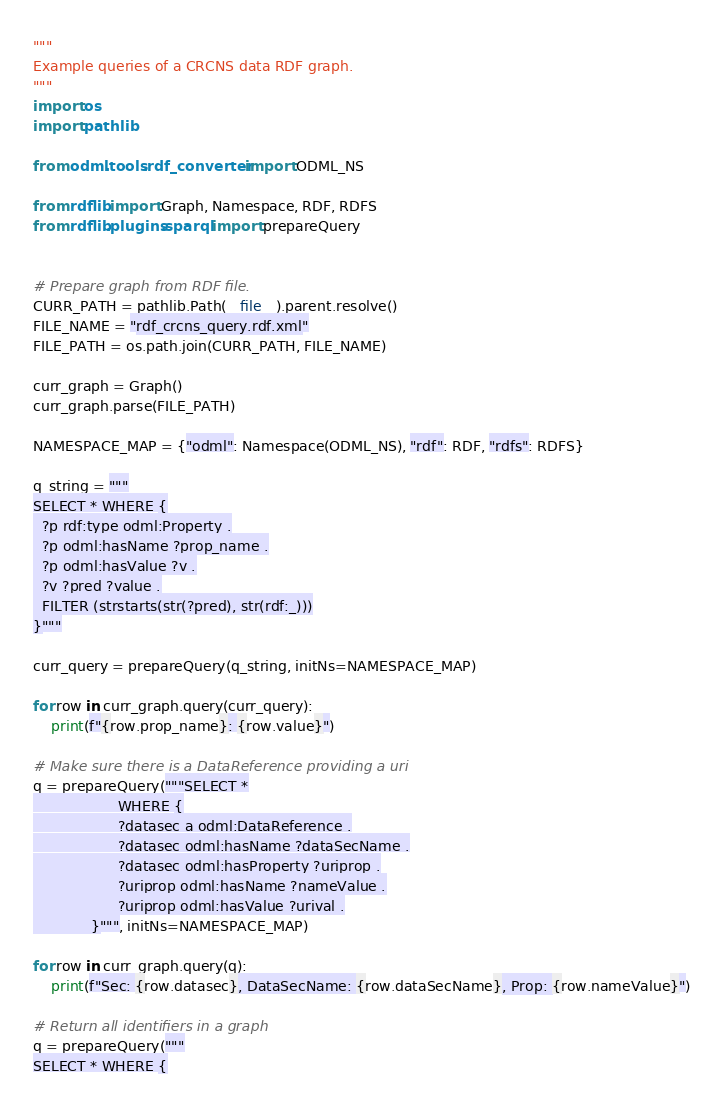Convert code to text. <code><loc_0><loc_0><loc_500><loc_500><_Python_>"""
Example queries of a CRCNS data RDF graph.
"""
import os
import pathlib

from odml.tools.rdf_converter import ODML_NS

from rdflib import Graph, Namespace, RDF, RDFS
from rdflib.plugins.sparql import prepareQuery


# Prepare graph from RDF file.
CURR_PATH = pathlib.Path(__file__).parent.resolve()
FILE_NAME = "rdf_crcns_query.rdf.xml"
FILE_PATH = os.path.join(CURR_PATH, FILE_NAME)

curr_graph = Graph()
curr_graph.parse(FILE_PATH)

NAMESPACE_MAP = {"odml": Namespace(ODML_NS), "rdf": RDF, "rdfs": RDFS}

q_string = """
SELECT * WHERE {
  ?p rdf:type odml:Property .
  ?p odml:hasName ?prop_name .
  ?p odml:hasValue ?v .
  ?v ?pred ?value .
  FILTER (strstarts(str(?pred), str(rdf:_)))
}"""

curr_query = prepareQuery(q_string, initNs=NAMESPACE_MAP)

for row in curr_graph.query(curr_query):
    print(f"{row.prop_name}: {row.value}")

# Make sure there is a DataReference providing a uri
q = prepareQuery("""SELECT *
                   WHERE {
                   ?datasec a odml:DataReference .
                   ?datasec odml:hasName ?dataSecName .
                   ?datasec odml:hasProperty ?uriprop .
                   ?uriprop odml:hasName ?nameValue .
                   ?uriprop odml:hasValue ?urival .
             }""", initNs=NAMESPACE_MAP)

for row in curr_graph.query(q):
    print(f"Sec: {row.datasec}, DataSecName: {row.dataSecName}, Prop: {row.nameValue}")

# Return all identifiers in a graph
q = prepareQuery("""
SELECT * WHERE {</code> 